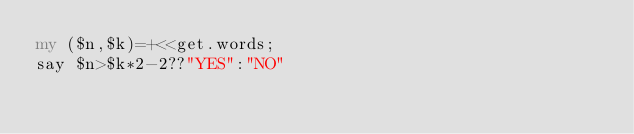<code> <loc_0><loc_0><loc_500><loc_500><_Perl_>my ($n,$k)=+<<get.words;
say $n>$k*2-2??"YES":"NO"</code> 